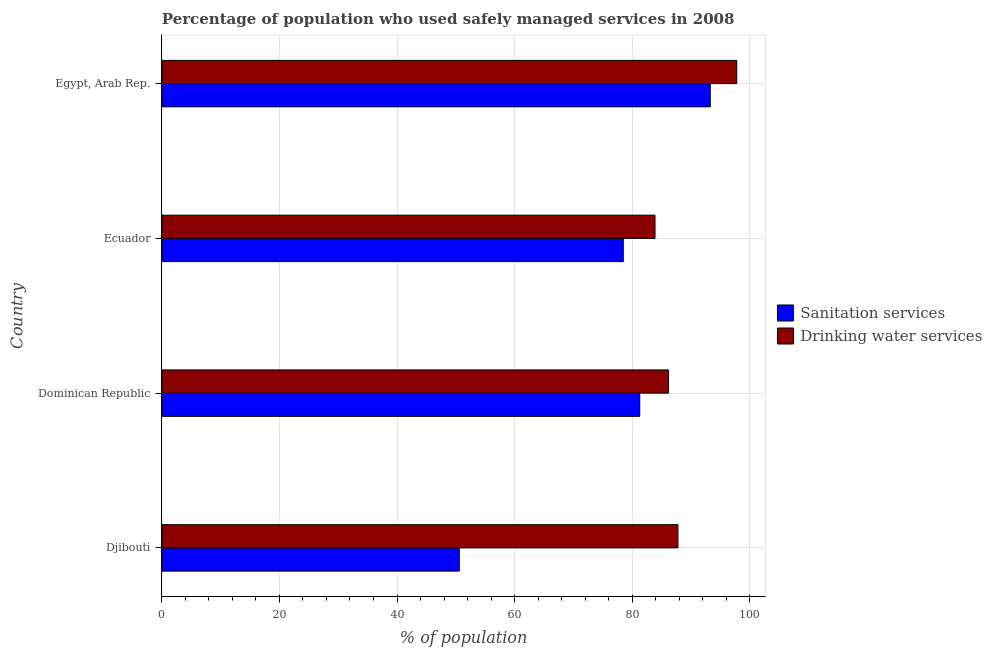How many different coloured bars are there?
Your response must be concise. 2. How many groups of bars are there?
Ensure brevity in your answer.  4. Are the number of bars per tick equal to the number of legend labels?
Provide a succinct answer. Yes. How many bars are there on the 1st tick from the top?
Make the answer very short. 2. How many bars are there on the 3rd tick from the bottom?
Offer a terse response. 2. What is the label of the 2nd group of bars from the top?
Offer a terse response. Ecuador. What is the percentage of population who used drinking water services in Egypt, Arab Rep.?
Offer a very short reply. 97.8. Across all countries, what is the maximum percentage of population who used sanitation services?
Offer a terse response. 93.3. Across all countries, what is the minimum percentage of population who used sanitation services?
Your response must be concise. 50.6. In which country was the percentage of population who used drinking water services maximum?
Ensure brevity in your answer.  Egypt, Arab Rep. In which country was the percentage of population who used drinking water services minimum?
Your answer should be compact. Ecuador. What is the total percentage of population who used drinking water services in the graph?
Keep it short and to the point. 355.7. What is the difference between the percentage of population who used drinking water services in Djibouti and that in Ecuador?
Your answer should be very brief. 3.9. What is the difference between the percentage of population who used sanitation services in Ecuador and the percentage of population who used drinking water services in Dominican Republic?
Offer a terse response. -7.7. What is the average percentage of population who used drinking water services per country?
Your answer should be very brief. 88.92. What is the difference between the percentage of population who used sanitation services and percentage of population who used drinking water services in Egypt, Arab Rep.?
Offer a very short reply. -4.5. In how many countries, is the percentage of population who used drinking water services greater than 84 %?
Ensure brevity in your answer.  3. What is the ratio of the percentage of population who used sanitation services in Ecuador to that in Egypt, Arab Rep.?
Offer a terse response. 0.84. Is the difference between the percentage of population who used sanitation services in Dominican Republic and Ecuador greater than the difference between the percentage of population who used drinking water services in Dominican Republic and Ecuador?
Provide a short and direct response. Yes. What is the difference between the highest and the second highest percentage of population who used sanitation services?
Your answer should be very brief. 12. What is the difference between the highest and the lowest percentage of population who used sanitation services?
Your answer should be very brief. 42.7. In how many countries, is the percentage of population who used drinking water services greater than the average percentage of population who used drinking water services taken over all countries?
Offer a very short reply. 1. What does the 1st bar from the top in Djibouti represents?
Keep it short and to the point. Drinking water services. What does the 2nd bar from the bottom in Djibouti represents?
Your answer should be compact. Drinking water services. How many bars are there?
Keep it short and to the point. 8. Are all the bars in the graph horizontal?
Your answer should be compact. Yes. How many countries are there in the graph?
Offer a very short reply. 4. Are the values on the major ticks of X-axis written in scientific E-notation?
Provide a short and direct response. No. Does the graph contain any zero values?
Your response must be concise. No. How are the legend labels stacked?
Keep it short and to the point. Vertical. What is the title of the graph?
Your answer should be compact. Percentage of population who used safely managed services in 2008. What is the label or title of the X-axis?
Offer a very short reply. % of population. What is the label or title of the Y-axis?
Make the answer very short. Country. What is the % of population in Sanitation services in Djibouti?
Your response must be concise. 50.6. What is the % of population in Drinking water services in Djibouti?
Provide a short and direct response. 87.8. What is the % of population in Sanitation services in Dominican Republic?
Keep it short and to the point. 81.3. What is the % of population of Drinking water services in Dominican Republic?
Give a very brief answer. 86.2. What is the % of population of Sanitation services in Ecuador?
Your answer should be compact. 78.5. What is the % of population of Drinking water services in Ecuador?
Make the answer very short. 83.9. What is the % of population in Sanitation services in Egypt, Arab Rep.?
Offer a terse response. 93.3. What is the % of population of Drinking water services in Egypt, Arab Rep.?
Your answer should be very brief. 97.8. Across all countries, what is the maximum % of population in Sanitation services?
Offer a very short reply. 93.3. Across all countries, what is the maximum % of population in Drinking water services?
Ensure brevity in your answer.  97.8. Across all countries, what is the minimum % of population of Sanitation services?
Give a very brief answer. 50.6. Across all countries, what is the minimum % of population in Drinking water services?
Make the answer very short. 83.9. What is the total % of population in Sanitation services in the graph?
Your response must be concise. 303.7. What is the total % of population of Drinking water services in the graph?
Your answer should be very brief. 355.7. What is the difference between the % of population of Sanitation services in Djibouti and that in Dominican Republic?
Your response must be concise. -30.7. What is the difference between the % of population of Sanitation services in Djibouti and that in Ecuador?
Provide a succinct answer. -27.9. What is the difference between the % of population of Sanitation services in Djibouti and that in Egypt, Arab Rep.?
Offer a very short reply. -42.7. What is the difference between the % of population of Sanitation services in Dominican Republic and that in Ecuador?
Provide a short and direct response. 2.8. What is the difference between the % of population in Drinking water services in Dominican Republic and that in Ecuador?
Provide a succinct answer. 2.3. What is the difference between the % of population of Sanitation services in Ecuador and that in Egypt, Arab Rep.?
Your answer should be compact. -14.8. What is the difference between the % of population of Sanitation services in Djibouti and the % of population of Drinking water services in Dominican Republic?
Offer a terse response. -35.6. What is the difference between the % of population of Sanitation services in Djibouti and the % of population of Drinking water services in Ecuador?
Ensure brevity in your answer.  -33.3. What is the difference between the % of population in Sanitation services in Djibouti and the % of population in Drinking water services in Egypt, Arab Rep.?
Your answer should be compact. -47.2. What is the difference between the % of population of Sanitation services in Dominican Republic and the % of population of Drinking water services in Egypt, Arab Rep.?
Offer a very short reply. -16.5. What is the difference between the % of population in Sanitation services in Ecuador and the % of population in Drinking water services in Egypt, Arab Rep.?
Offer a very short reply. -19.3. What is the average % of population of Sanitation services per country?
Make the answer very short. 75.92. What is the average % of population in Drinking water services per country?
Your response must be concise. 88.92. What is the difference between the % of population in Sanitation services and % of population in Drinking water services in Djibouti?
Keep it short and to the point. -37.2. What is the difference between the % of population in Sanitation services and % of population in Drinking water services in Ecuador?
Ensure brevity in your answer.  -5.4. What is the difference between the % of population of Sanitation services and % of population of Drinking water services in Egypt, Arab Rep.?
Your response must be concise. -4.5. What is the ratio of the % of population of Sanitation services in Djibouti to that in Dominican Republic?
Make the answer very short. 0.62. What is the ratio of the % of population of Drinking water services in Djibouti to that in Dominican Republic?
Provide a short and direct response. 1.02. What is the ratio of the % of population in Sanitation services in Djibouti to that in Ecuador?
Make the answer very short. 0.64. What is the ratio of the % of population of Drinking water services in Djibouti to that in Ecuador?
Ensure brevity in your answer.  1.05. What is the ratio of the % of population in Sanitation services in Djibouti to that in Egypt, Arab Rep.?
Ensure brevity in your answer.  0.54. What is the ratio of the % of population of Drinking water services in Djibouti to that in Egypt, Arab Rep.?
Keep it short and to the point. 0.9. What is the ratio of the % of population of Sanitation services in Dominican Republic to that in Ecuador?
Offer a very short reply. 1.04. What is the ratio of the % of population of Drinking water services in Dominican Republic to that in Ecuador?
Your response must be concise. 1.03. What is the ratio of the % of population in Sanitation services in Dominican Republic to that in Egypt, Arab Rep.?
Offer a terse response. 0.87. What is the ratio of the % of population in Drinking water services in Dominican Republic to that in Egypt, Arab Rep.?
Ensure brevity in your answer.  0.88. What is the ratio of the % of population of Sanitation services in Ecuador to that in Egypt, Arab Rep.?
Provide a short and direct response. 0.84. What is the ratio of the % of population in Drinking water services in Ecuador to that in Egypt, Arab Rep.?
Your answer should be compact. 0.86. What is the difference between the highest and the second highest % of population in Drinking water services?
Offer a very short reply. 10. What is the difference between the highest and the lowest % of population of Sanitation services?
Make the answer very short. 42.7. What is the difference between the highest and the lowest % of population in Drinking water services?
Offer a terse response. 13.9. 